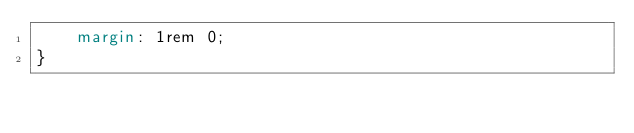Convert code to text. <code><loc_0><loc_0><loc_500><loc_500><_CSS_>	margin: 1rem 0;
}
</code> 